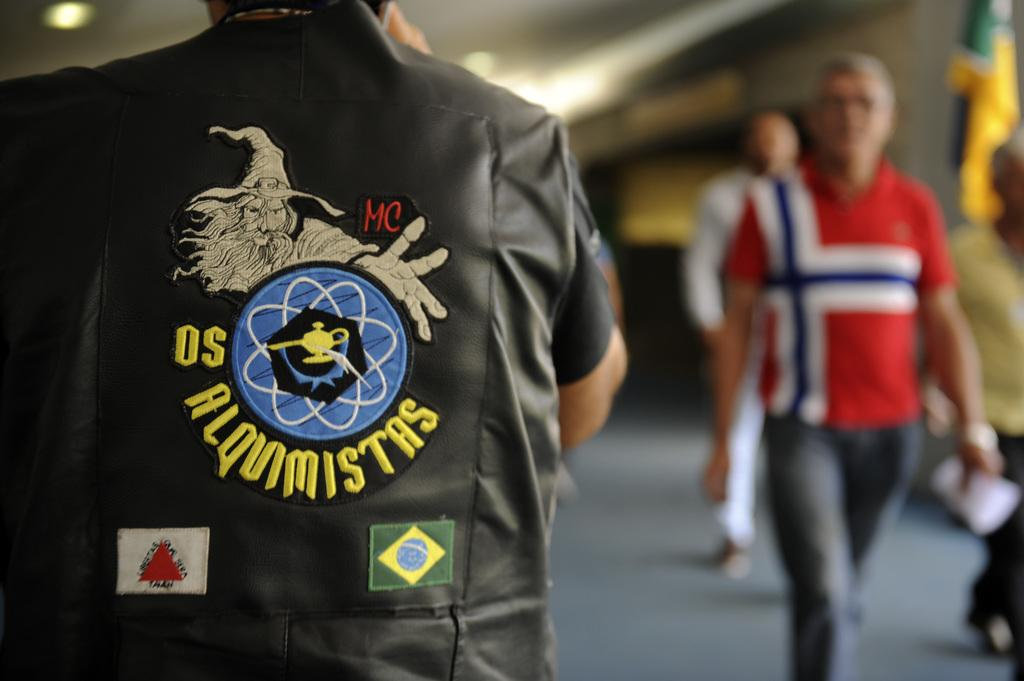<image>
Share a concise interpretation of the image provided. a man in a jacket with the letters OS on it 